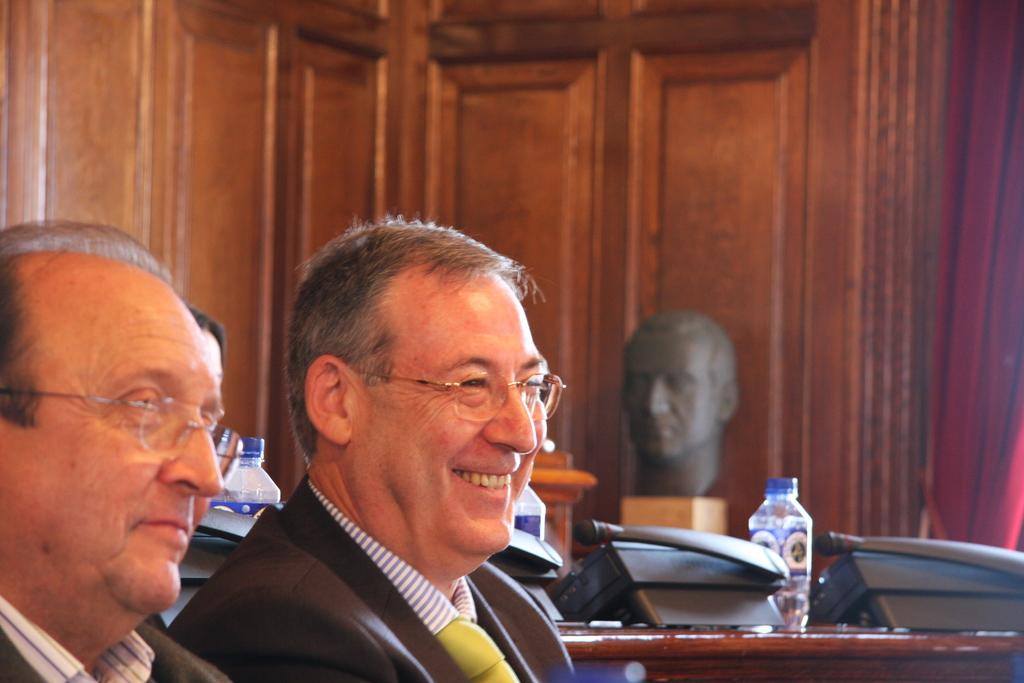How many people are in the image? There are two men in the image. What are the men wearing? Both men are wearing glasses. Can you describe the facial expression of one of the men? One of the men is smiling. What can be seen in the background of the image? There are water bottles in the background of the image. What type of dirt can be seen on the men's shoes in the image? There is no dirt visible on the men's shoes in the image. Are the men playing any games or engaging in any activities in the image? The provided facts do not mention any games or activities, so it cannot be determined from the image. 